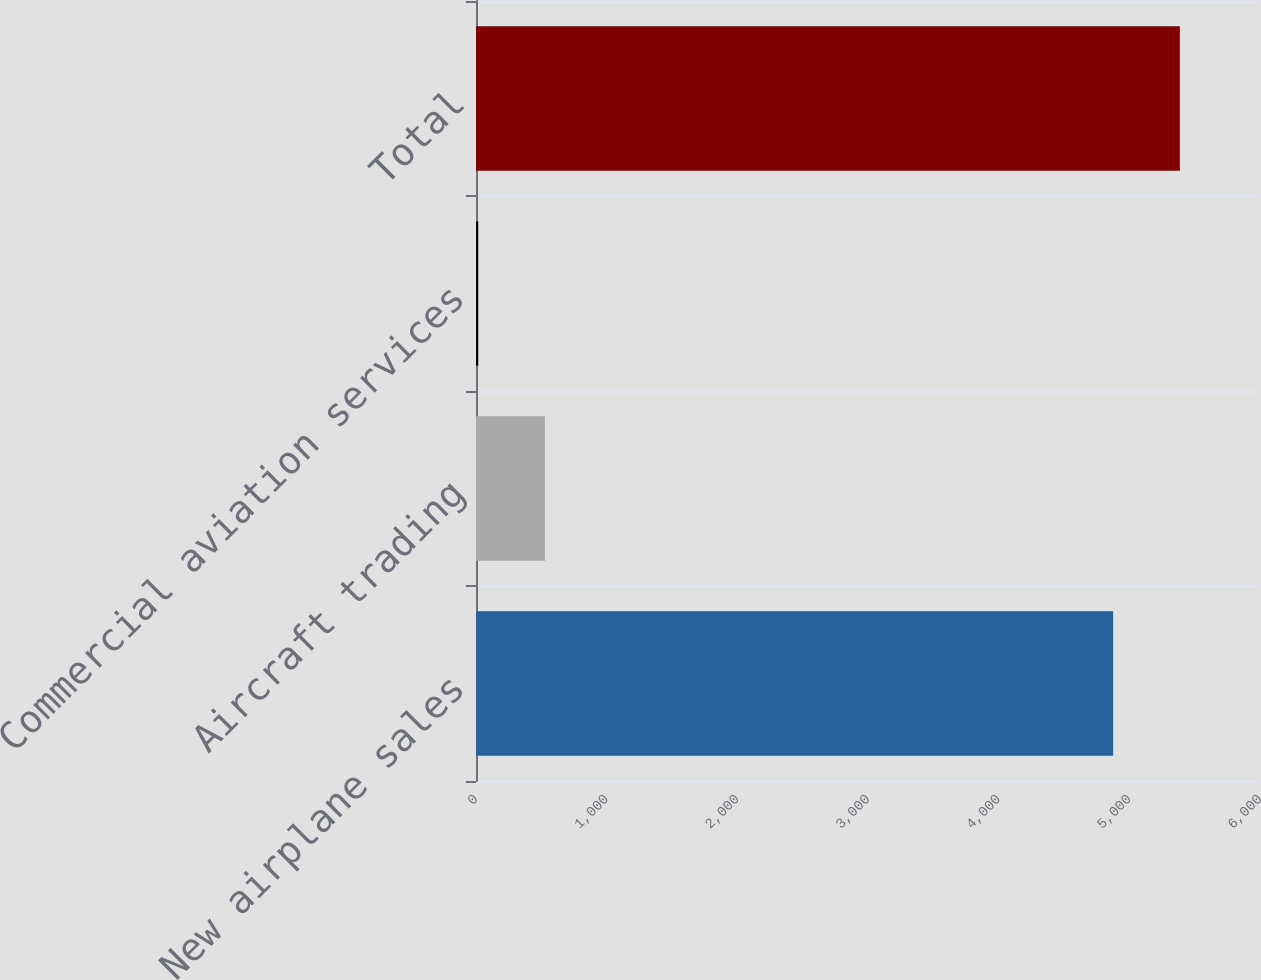<chart> <loc_0><loc_0><loc_500><loc_500><bar_chart><fcel>New airplane sales<fcel>Aircraft trading<fcel>Commercial aviation services<fcel>Total<nl><fcel>4876<fcel>527.6<fcel>17<fcel>5386.6<nl></chart> 